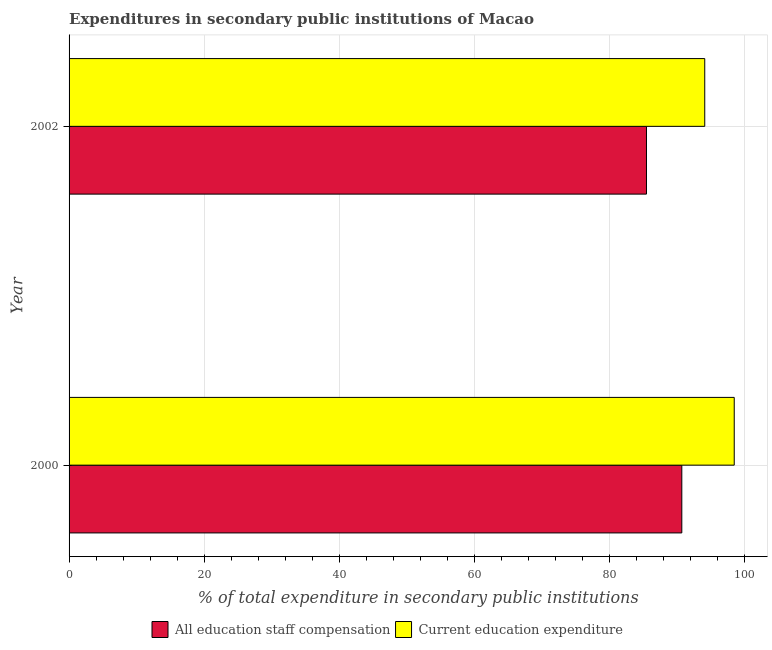How many different coloured bars are there?
Offer a terse response. 2. How many groups of bars are there?
Keep it short and to the point. 2. Are the number of bars per tick equal to the number of legend labels?
Offer a terse response. Yes. Are the number of bars on each tick of the Y-axis equal?
Give a very brief answer. Yes. What is the label of the 2nd group of bars from the top?
Ensure brevity in your answer.  2000. What is the expenditure in education in 2002?
Provide a short and direct response. 94.18. Across all years, what is the maximum expenditure in staff compensation?
Your answer should be very brief. 90.78. Across all years, what is the minimum expenditure in education?
Provide a succinct answer. 94.18. In which year was the expenditure in education maximum?
Give a very brief answer. 2000. In which year was the expenditure in education minimum?
Keep it short and to the point. 2002. What is the total expenditure in education in the graph?
Offer a terse response. 192.72. What is the difference between the expenditure in education in 2000 and that in 2002?
Make the answer very short. 4.37. What is the difference between the expenditure in education in 2002 and the expenditure in staff compensation in 2000?
Provide a succinct answer. 3.4. What is the average expenditure in education per year?
Give a very brief answer. 96.36. In the year 2000, what is the difference between the expenditure in education and expenditure in staff compensation?
Your answer should be compact. 7.77. What is the ratio of the expenditure in education in 2000 to that in 2002?
Your answer should be compact. 1.05. Is the expenditure in staff compensation in 2000 less than that in 2002?
Your answer should be compact. No. In how many years, is the expenditure in education greater than the average expenditure in education taken over all years?
Offer a terse response. 1. What does the 1st bar from the top in 2000 represents?
Keep it short and to the point. Current education expenditure. What does the 1st bar from the bottom in 2000 represents?
Your answer should be compact. All education staff compensation. Are all the bars in the graph horizontal?
Offer a terse response. Yes. Does the graph contain any zero values?
Your answer should be very brief. No. Does the graph contain grids?
Your answer should be compact. Yes. How many legend labels are there?
Your answer should be very brief. 2. How are the legend labels stacked?
Keep it short and to the point. Horizontal. What is the title of the graph?
Your response must be concise. Expenditures in secondary public institutions of Macao. What is the label or title of the X-axis?
Offer a terse response. % of total expenditure in secondary public institutions. What is the % of total expenditure in secondary public institutions in All education staff compensation in 2000?
Offer a terse response. 90.78. What is the % of total expenditure in secondary public institutions in Current education expenditure in 2000?
Give a very brief answer. 98.54. What is the % of total expenditure in secondary public institutions of All education staff compensation in 2002?
Offer a terse response. 85.54. What is the % of total expenditure in secondary public institutions of Current education expenditure in 2002?
Give a very brief answer. 94.18. Across all years, what is the maximum % of total expenditure in secondary public institutions of All education staff compensation?
Make the answer very short. 90.78. Across all years, what is the maximum % of total expenditure in secondary public institutions of Current education expenditure?
Your answer should be very brief. 98.54. Across all years, what is the minimum % of total expenditure in secondary public institutions of All education staff compensation?
Give a very brief answer. 85.54. Across all years, what is the minimum % of total expenditure in secondary public institutions in Current education expenditure?
Keep it short and to the point. 94.18. What is the total % of total expenditure in secondary public institutions in All education staff compensation in the graph?
Your answer should be compact. 176.32. What is the total % of total expenditure in secondary public institutions in Current education expenditure in the graph?
Your answer should be compact. 192.72. What is the difference between the % of total expenditure in secondary public institutions of All education staff compensation in 2000 and that in 2002?
Offer a very short reply. 5.23. What is the difference between the % of total expenditure in secondary public institutions of Current education expenditure in 2000 and that in 2002?
Give a very brief answer. 4.37. What is the difference between the % of total expenditure in secondary public institutions in All education staff compensation in 2000 and the % of total expenditure in secondary public institutions in Current education expenditure in 2002?
Your answer should be very brief. -3.4. What is the average % of total expenditure in secondary public institutions in All education staff compensation per year?
Ensure brevity in your answer.  88.16. What is the average % of total expenditure in secondary public institutions of Current education expenditure per year?
Provide a short and direct response. 96.36. In the year 2000, what is the difference between the % of total expenditure in secondary public institutions of All education staff compensation and % of total expenditure in secondary public institutions of Current education expenditure?
Provide a succinct answer. -7.77. In the year 2002, what is the difference between the % of total expenditure in secondary public institutions of All education staff compensation and % of total expenditure in secondary public institutions of Current education expenditure?
Your response must be concise. -8.63. What is the ratio of the % of total expenditure in secondary public institutions of All education staff compensation in 2000 to that in 2002?
Your answer should be compact. 1.06. What is the ratio of the % of total expenditure in secondary public institutions of Current education expenditure in 2000 to that in 2002?
Your answer should be very brief. 1.05. What is the difference between the highest and the second highest % of total expenditure in secondary public institutions in All education staff compensation?
Ensure brevity in your answer.  5.23. What is the difference between the highest and the second highest % of total expenditure in secondary public institutions of Current education expenditure?
Keep it short and to the point. 4.37. What is the difference between the highest and the lowest % of total expenditure in secondary public institutions of All education staff compensation?
Offer a terse response. 5.23. What is the difference between the highest and the lowest % of total expenditure in secondary public institutions of Current education expenditure?
Make the answer very short. 4.37. 